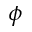Convert formula to latex. <formula><loc_0><loc_0><loc_500><loc_500>\phi</formula> 